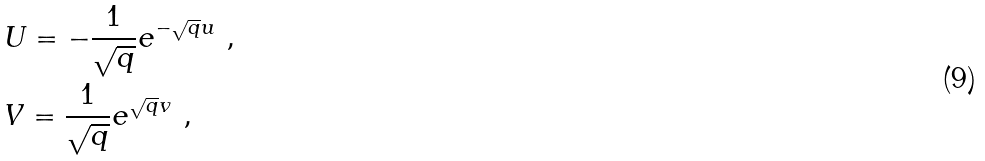<formula> <loc_0><loc_0><loc_500><loc_500>& U = - \frac { 1 } { \sqrt { q } } e ^ { - \sqrt { q } u } \ , \\ & V = \frac { 1 } { \sqrt { q } } e ^ { \sqrt { q } v } \ ,</formula> 